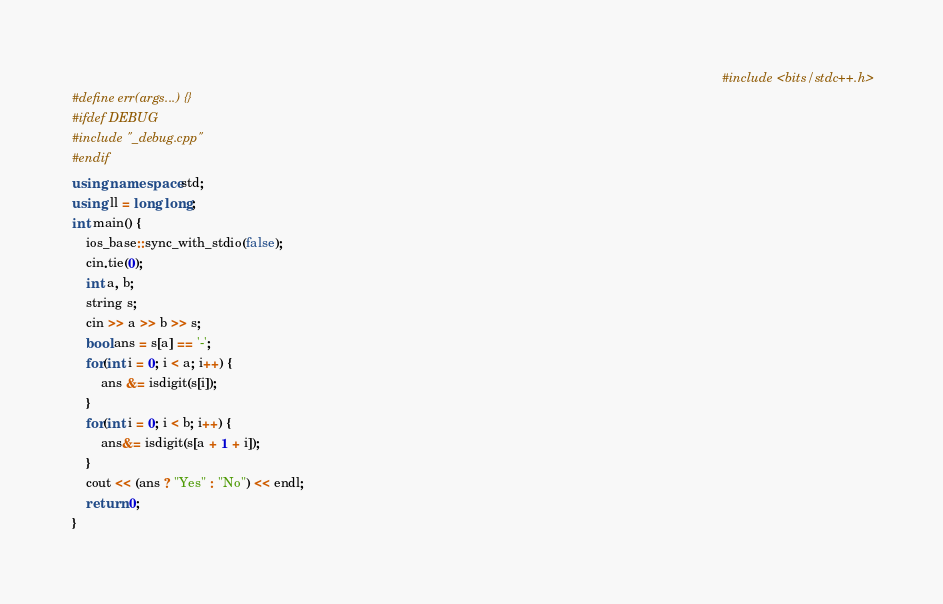Convert code to text. <code><loc_0><loc_0><loc_500><loc_500><_C++_>																																													#include <bits/stdc++.h>
#define err(args...) {}
#ifdef DEBUG
#include "_debug.cpp"
#endif
using namespace std;
using ll = long long;
int main() {
    ios_base::sync_with_stdio(false);
    cin.tie(0);
    int a, b;
    string s;
    cin >> a >> b >> s;
    bool ans = s[a] == '-';
    for(int i = 0; i < a; i++) {
        ans &= isdigit(s[i]);
    }
    for(int i = 0; i < b; i++) {
        ans&= isdigit(s[a + 1 + i]);
    }
    cout << (ans ? "Yes" : "No") << endl;
    return 0;
}
</code> 